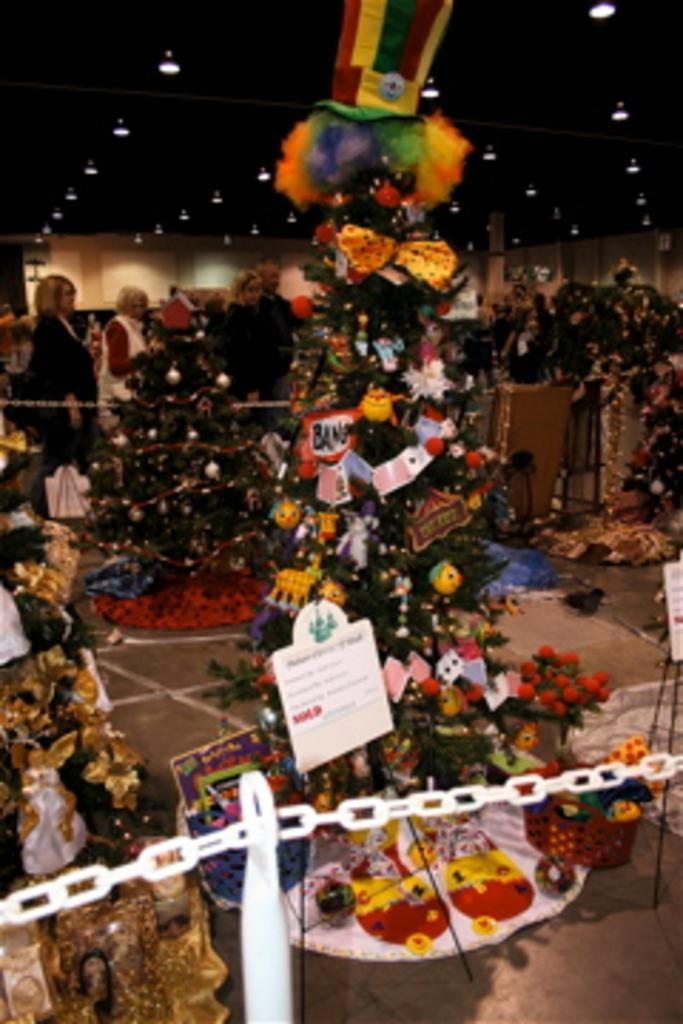Describe this image in one or two sentences. In this image there are group of people , there are trees decorated with balls, ribbons and toys , and there are boards and chain barriers , and in the background there are lights. 